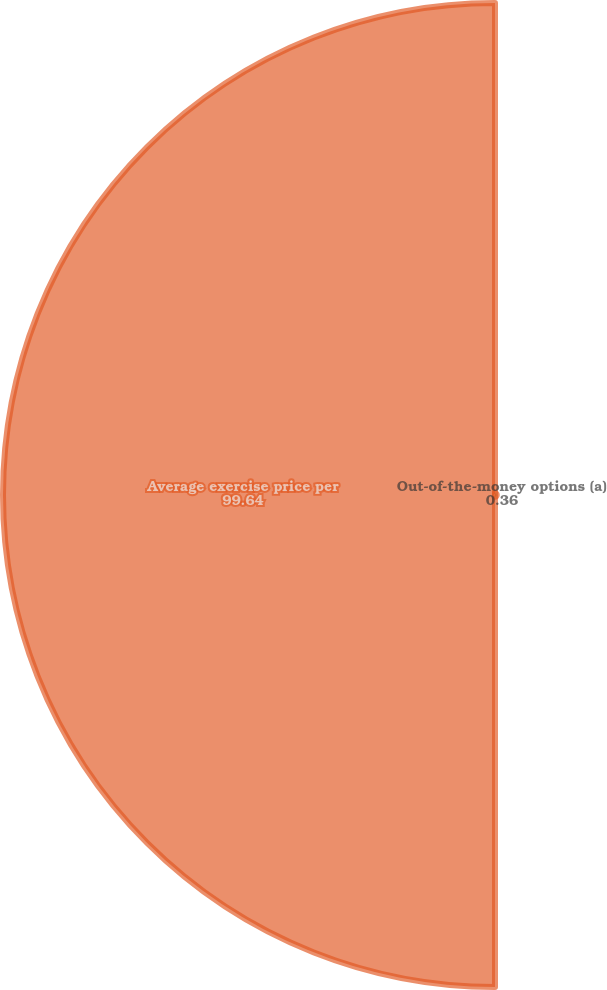<chart> <loc_0><loc_0><loc_500><loc_500><pie_chart><fcel>Out-of-the-money options (a)<fcel>Average exercise price per<nl><fcel>0.36%<fcel>99.64%<nl></chart> 